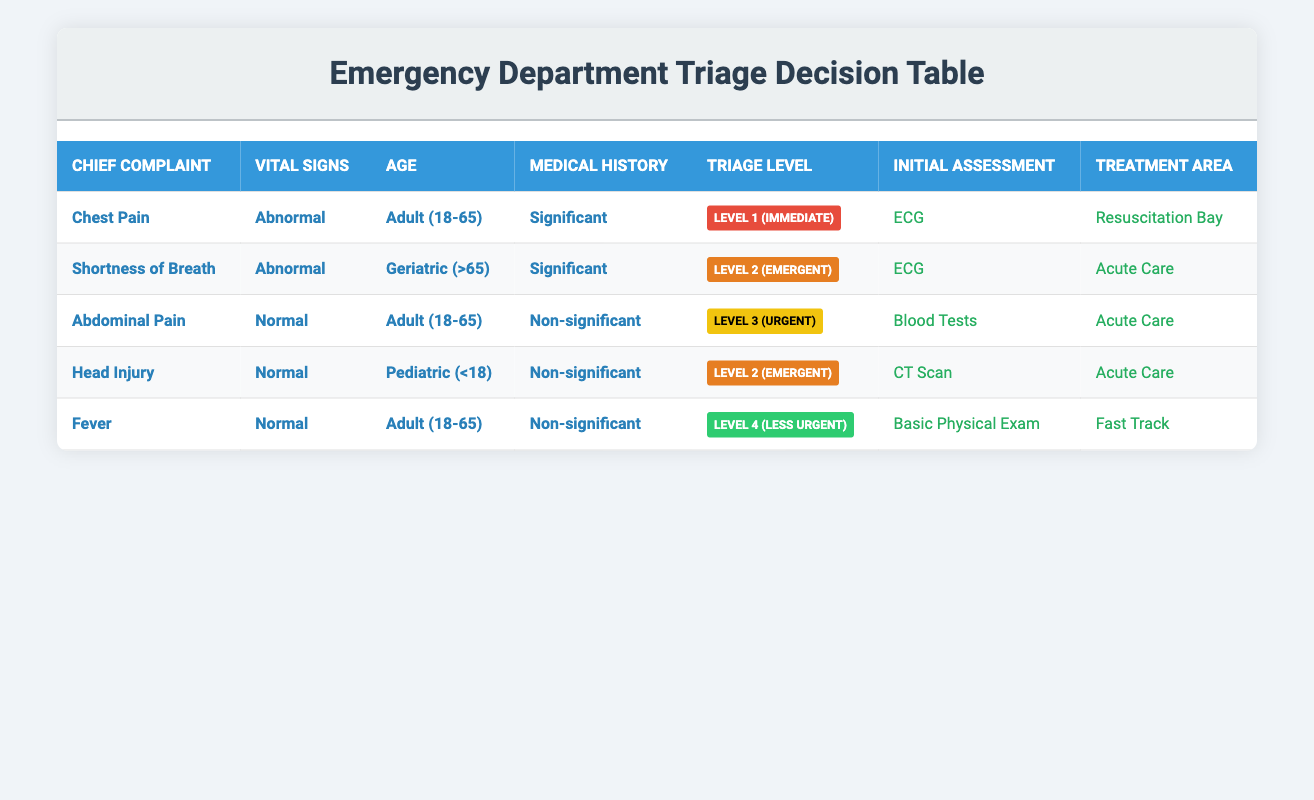What is the triage level for a patient with chest pain and abnormal vital signs? The row corresponding to chest pain with abnormal vital signs indicates a triage level of Level 1 (Immediate).
Answer: Level 1 (Immediate) How many patients with abnormal vital signs fall into the geriatric age category? There is one entry for a patient with abnormal vital signs in the geriatric age category (Shortness of Breath, Geriatric, Significant), indicating just one such patient.
Answer: 1 What initial assessment is required for a patient with abdominal pain and normal vital signs? The entry for abdominal pain with normal vital signs states that the initial assessment required is blood tests.
Answer: Blood Tests Are there any patients with a chief complaint of fever and significant medical history? By examining the table, none of the patients with a chief complaint of fever fall under the significant medical history category; therefore, the answer is no.
Answer: No What is the sum of the triage levels for patients with abnormal vital signs? Levels are: Chest Pain (1), Shortness of Breath (2), so the sum is 1 + 2 = 3.
Answer: 3 Which treatment area is assigned to patients with a chief complaint of head injury? The condition for head injury specifies that the treatment area is Acute Care.
Answer: Acute Care List all initial assessments required for patients in the acute care treatment area. The entries for acute care are: ECG (chest pain), ECG (shortness of breath), Blood Tests (abdominal pain), and CT Scan (head injury). This gives us ECG, Blood Tests, and CT Scan as initial assessments.
Answer: ECG, Blood Tests, CT Scan How many patients require an ECG as their initial assessment? By inspecting the table, there are two patients that require an ECG: one for chest pain and one for shortness of breath, totaling two patients.
Answer: 2 If a patient is pediatric (<18) with a normal medical history, what is their likely triage level and initial assessment? The entry for pediatric patients lists head injury with normal vital signs and a non-significant medical history, leading to a triage level of Level 2 (Emergent) and an initial assessment of CT Scan.
Answer: Level 2 (Emergent), CT Scan 